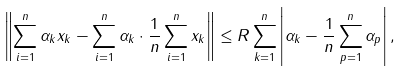<formula> <loc_0><loc_0><loc_500><loc_500>\left \| \sum _ { i = 1 } ^ { n } \alpha _ { k } x _ { k } - \sum _ { i = 1 } ^ { n } \alpha _ { k } \cdot \frac { 1 } { n } \sum _ { i = 1 } ^ { n } x _ { k } \right \| \leq R \sum _ { k = 1 } ^ { n } \left | \alpha _ { k } - \frac { 1 } { n } \sum _ { p = 1 } ^ { n } \alpha _ { p } \right | ,</formula> 